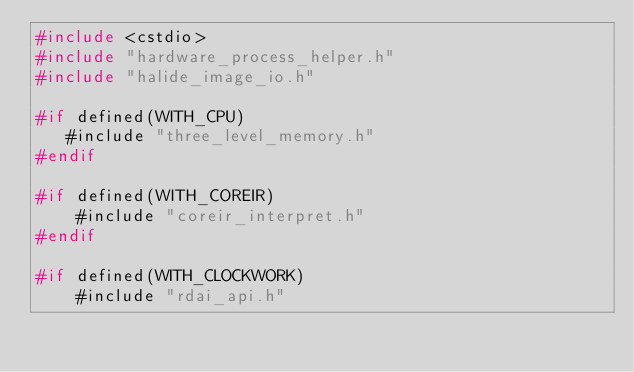Convert code to text. <code><loc_0><loc_0><loc_500><loc_500><_C++_>#include <cstdio>
#include "hardware_process_helper.h"
#include "halide_image_io.h"

#if defined(WITH_CPU)
   #include "three_level_memory.h"
#endif

#if defined(WITH_COREIR)
    #include "coreir_interpret.h"
#endif

#if defined(WITH_CLOCKWORK)
    #include "rdai_api.h"</code> 